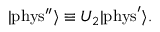Convert formula to latex. <formula><loc_0><loc_0><loc_500><loc_500>| { p h y s ^ { \prime \prime } } \rangle \equiv U _ { 2 } | { p h y s } ^ { \prime } \rangle .</formula> 